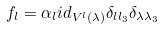<formula> <loc_0><loc_0><loc_500><loc_500>f _ { l } = \alpha _ { l } i d _ { V ^ { l } ( \lambda ) } \delta _ { l l _ { 3 } } \delta _ { \lambda \lambda _ { 3 } }</formula> 